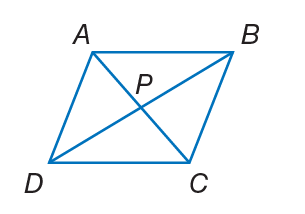Answer the mathemtical geometry problem and directly provide the correct option letter.
Question: A B C D is a rhombus. If P B = 12, A B = 15, and m \angle A B D = 24. Find m \angle A C B.
Choices: A: 15 B: 24 C: 27 D: 66 D 